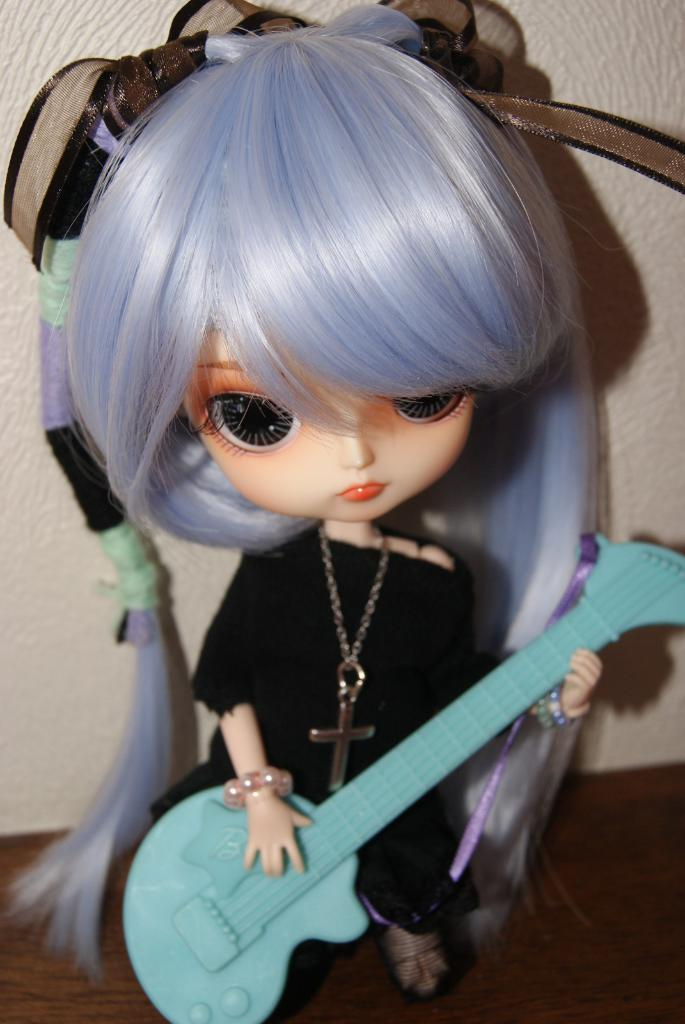What type of toy is in the image? There is a Barbie toy in the image. What is the Barbie toy wearing? The Barbie toy is dressed in a black color frock. What is the Barbie toy holding? The Barbie toy is holding a toy guitar. What can be seen in the background of the image? There is a wall in the background of the image. What is the weight of the steel friend in the image? There is no steel friend present in the image, and therefore no weight can be determined. 